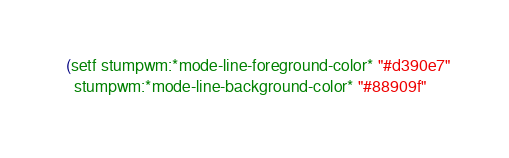<code> <loc_0><loc_0><loc_500><loc_500><_Lisp_>
  (setf stumpwm:*mode-line-foreground-color* "#d390e7"
	stumpwm:*mode-line-background-color* "#88909f"</code> 